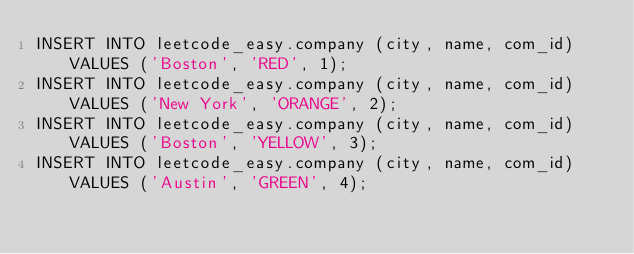<code> <loc_0><loc_0><loc_500><loc_500><_SQL_>INSERT INTO leetcode_easy.company (city, name, com_id) VALUES ('Boston', 'RED', 1);
INSERT INTO leetcode_easy.company (city, name, com_id) VALUES ('New York', 'ORANGE', 2);
INSERT INTO leetcode_easy.company (city, name, com_id) VALUES ('Boston', 'YELLOW', 3);
INSERT INTO leetcode_easy.company (city, name, com_id) VALUES ('Austin', 'GREEN', 4);</code> 